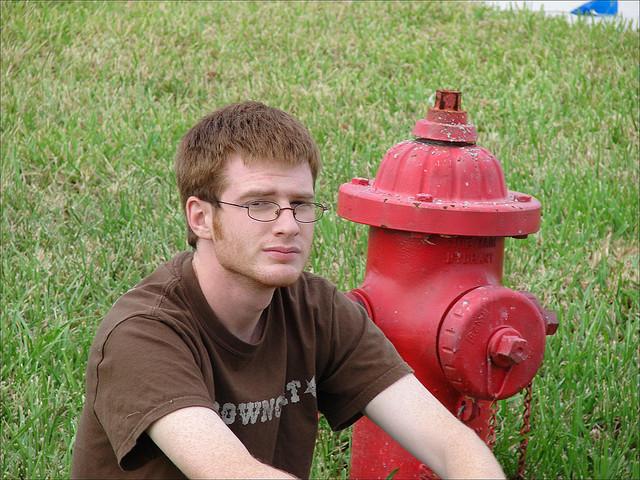Does the boy look happy?
Be succinct. No. What color is the top of the hydrant?
Quick response, please. Red. What is the boy sitting next to?
Concise answer only. Fire hydrant. What color is the man shirt?
Keep it brief. Brown. 